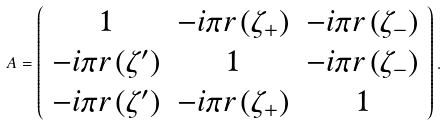<formula> <loc_0><loc_0><loc_500><loc_500>A = \left ( \begin{array} { c c c } 1 & - i \pi r \left ( \zeta _ { + } \right ) & - i \pi r \left ( \zeta _ { - } \right ) \\ - i \pi r \left ( \zeta ^ { \prime } \right ) & 1 & - i \pi r \left ( \zeta _ { - } \right ) \\ - i \pi r \left ( \zeta ^ { \prime } \right ) & - i \pi r \left ( \zeta _ { + } \right ) & 1 \end{array} \right ) .</formula> 